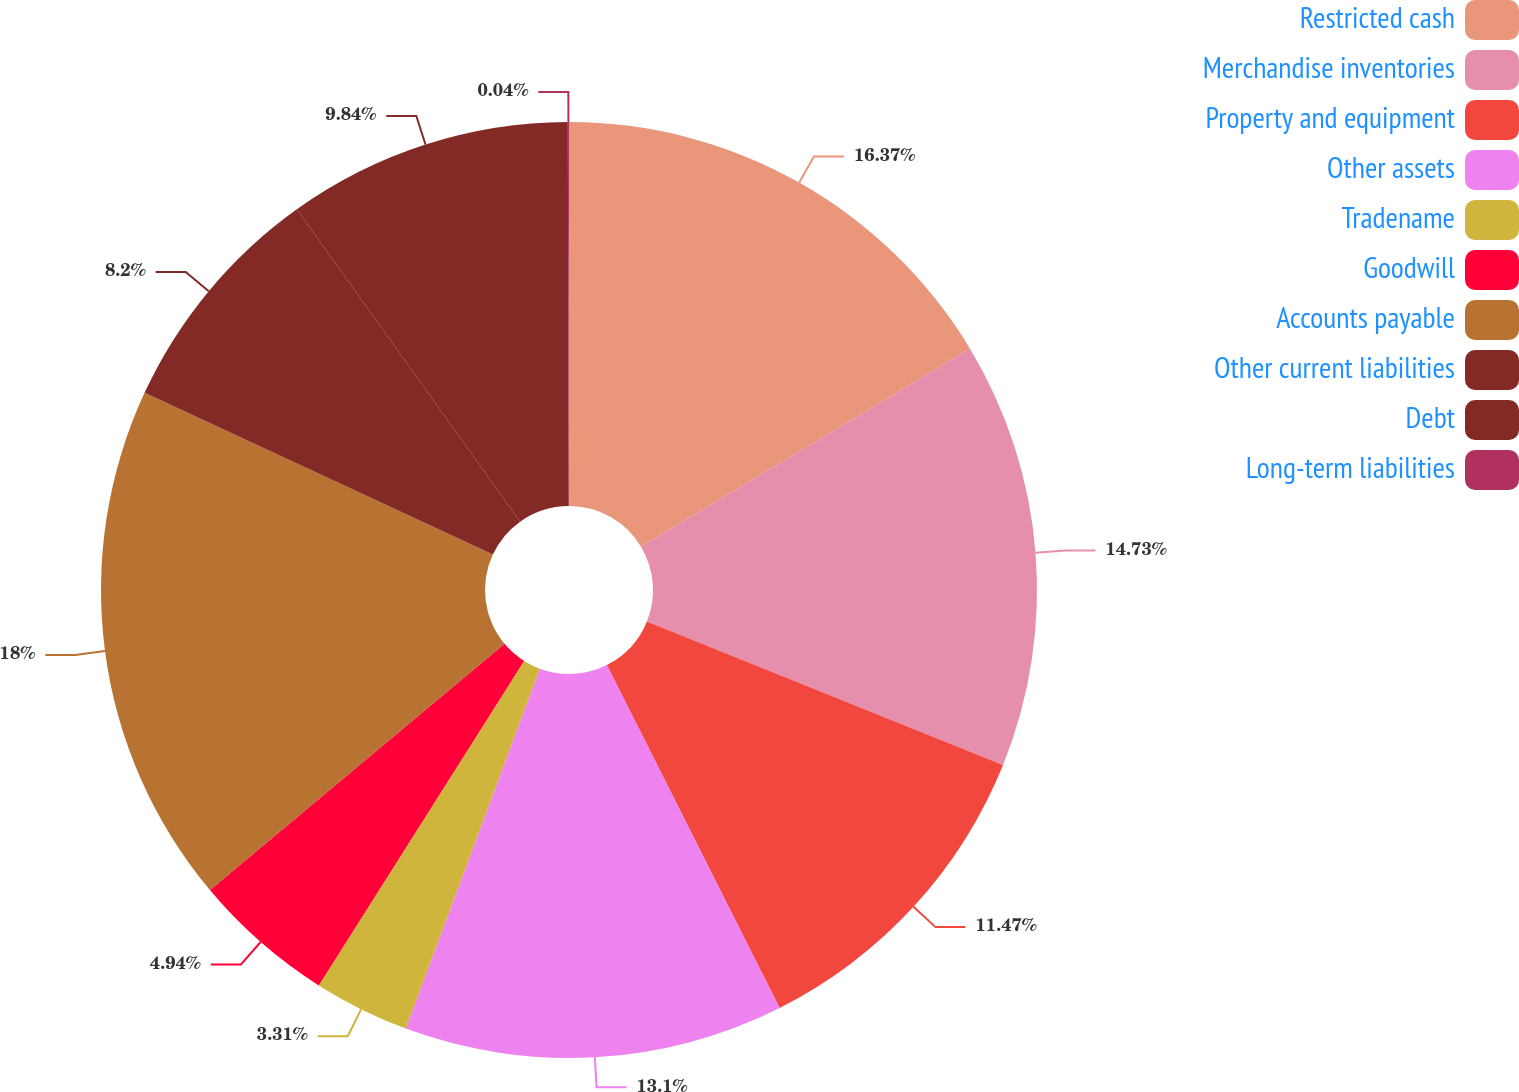<chart> <loc_0><loc_0><loc_500><loc_500><pie_chart><fcel>Restricted cash<fcel>Merchandise inventories<fcel>Property and equipment<fcel>Other assets<fcel>Tradename<fcel>Goodwill<fcel>Accounts payable<fcel>Other current liabilities<fcel>Debt<fcel>Long-term liabilities<nl><fcel>16.37%<fcel>14.73%<fcel>11.47%<fcel>13.1%<fcel>3.31%<fcel>4.94%<fcel>18.0%<fcel>8.2%<fcel>9.84%<fcel>0.04%<nl></chart> 